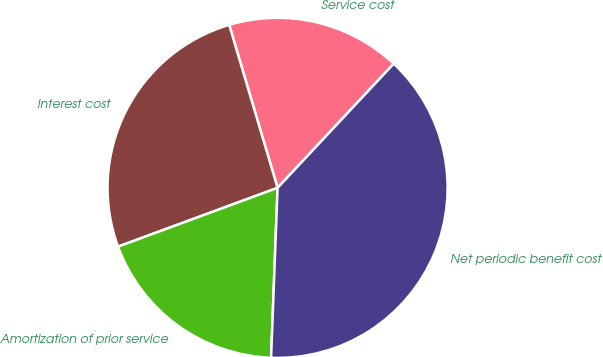<chart> <loc_0><loc_0><loc_500><loc_500><pie_chart><fcel>Service cost<fcel>Interest cost<fcel>Amortization of prior service<fcel>Net periodic benefit cost<nl><fcel>16.56%<fcel>26.03%<fcel>18.77%<fcel>38.64%<nl></chart> 